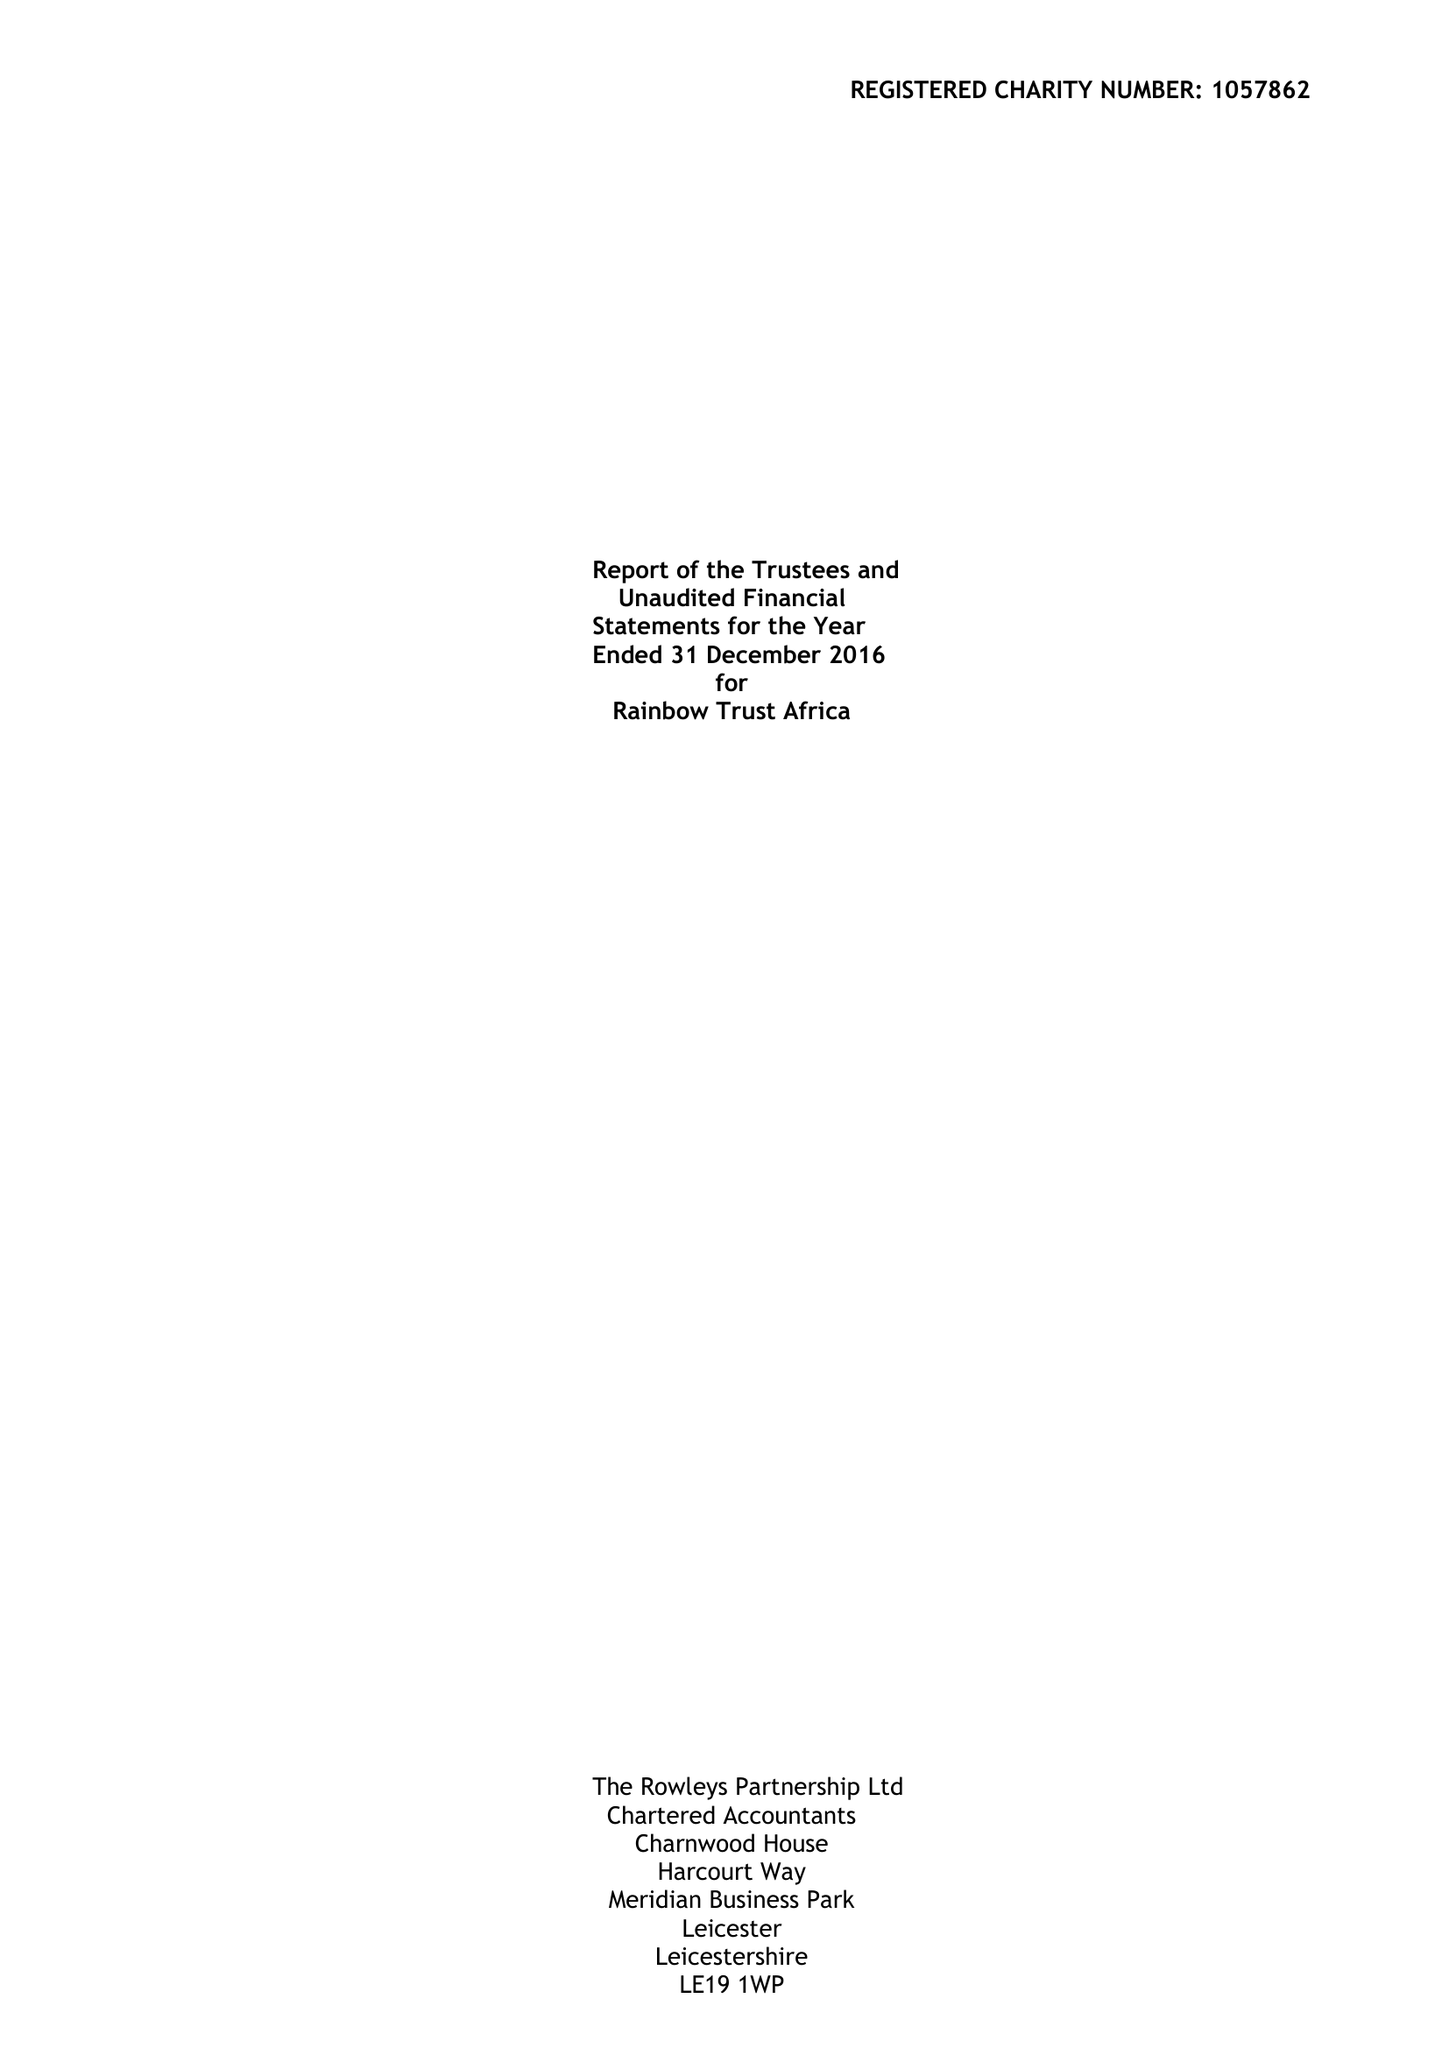What is the value for the report_date?
Answer the question using a single word or phrase. 2016-12-31 